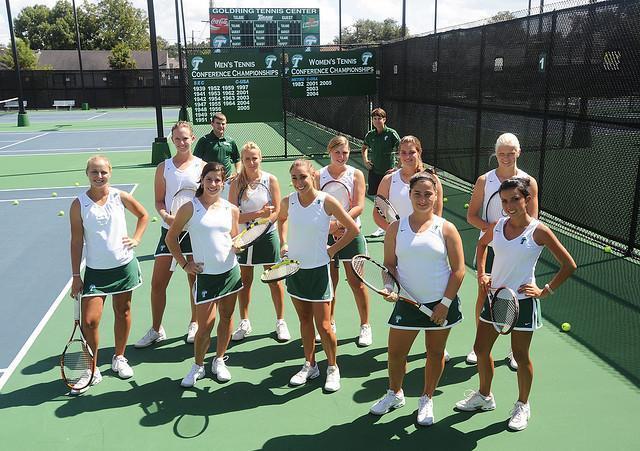How many women?
Give a very brief answer. 10. How many people can you see?
Give a very brief answer. 11. 